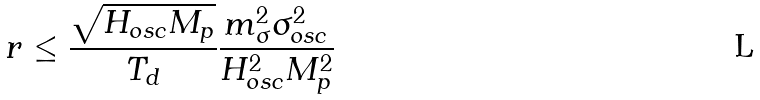<formula> <loc_0><loc_0><loc_500><loc_500>r \leq \frac { \sqrt { H _ { o s c } M _ { p } } } { T _ { d } } \frac { m _ { \sigma } ^ { 2 } \sigma _ { o s c } ^ { 2 } } { H _ { o s c } ^ { 2 } M _ { p } ^ { 2 } }</formula> 